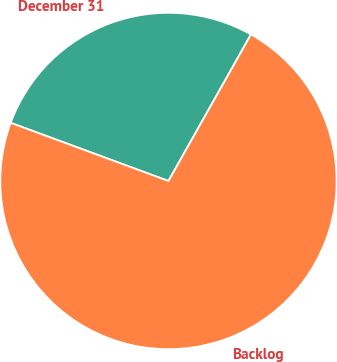Convert chart to OTSL. <chart><loc_0><loc_0><loc_500><loc_500><pie_chart><fcel>December 31<fcel>Backlog<nl><fcel>27.54%<fcel>72.46%<nl></chart> 